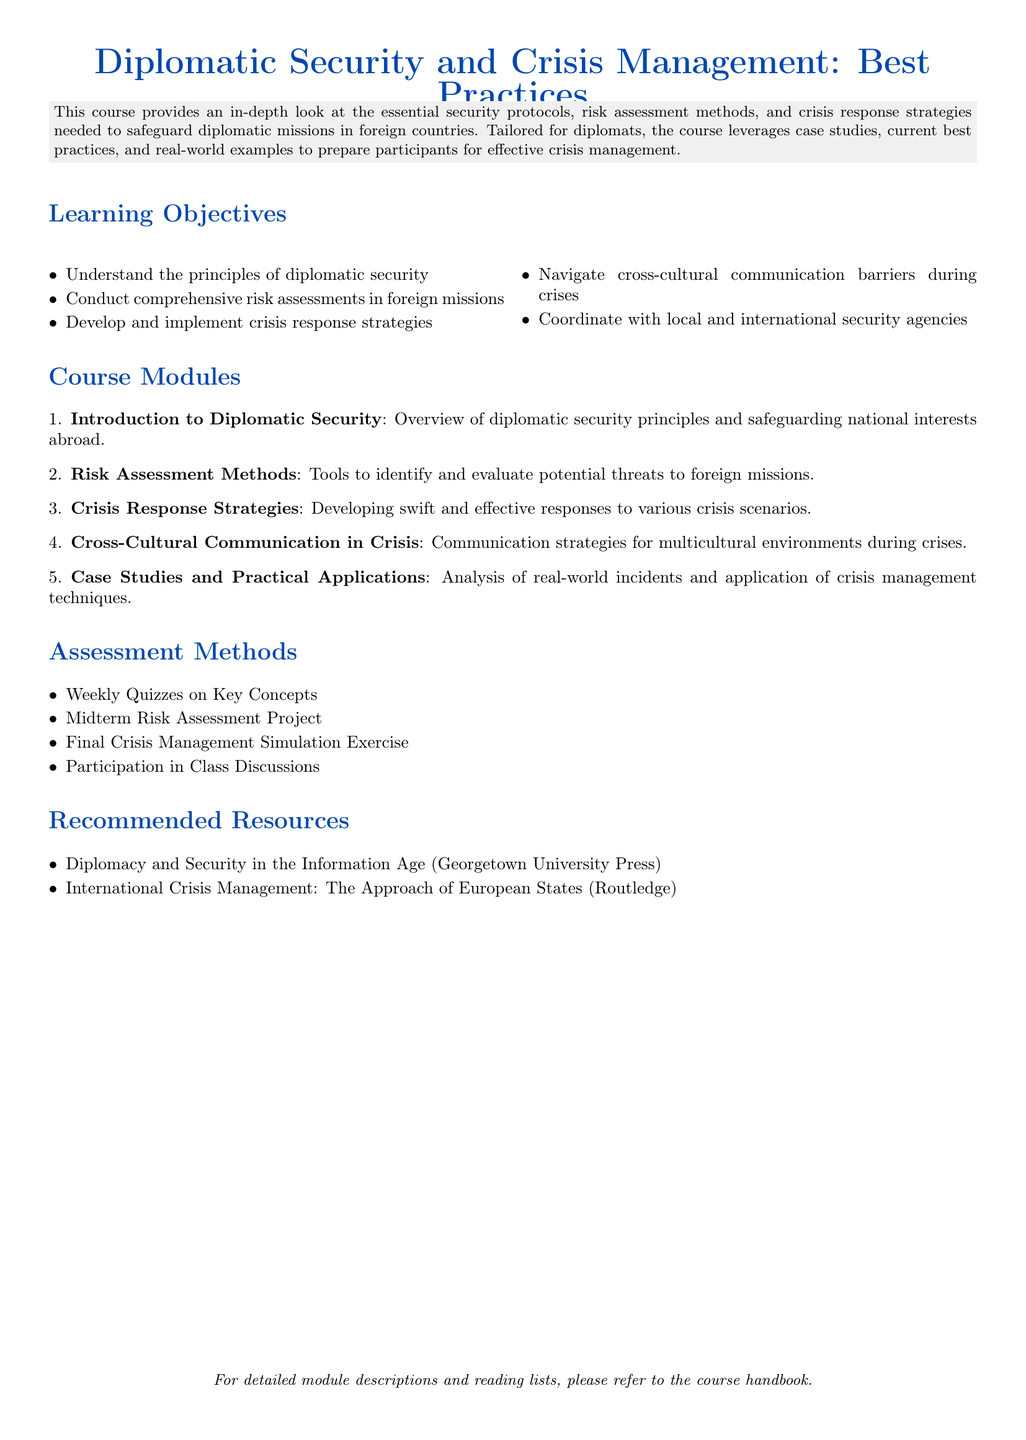What is the course title? The course title is stated at the beginning of the document.
Answer: Diplomatic Security and Crisis Management: Best Practices How many modules are listed in the syllabus? The number of modules can be counted from the enumerated list in the course modules section.
Answer: Five What is one recommended resource for the course? The document lists recommended resources in a specific section.
Answer: Diplomacy and Security in the Information Age What is the first learning objective? The learning objectives are listed in a specific order.
Answer: Understand the principles of diplomatic security What type of exercise is included in the assessment methods? The assessment methods list different types of evaluations for the course.
Answer: Final Crisis Management Simulation Exercise What is the focus of the second module? The modules provide specific focuses as outlined in the syllabus.
Answer: Risk Assessment Methods What is the purpose of "Case Studies and Practical Applications" module? The title suggests a focus on real-world incidents and practical techniques.
Answer: Analysis of real-world incidents What communication aspect is covered in the course? The learning objectives mention specific areas of focus including communications during crises.
Answer: Cross-cultural communication barriers during crises Which agency type is emphasized for coordination? The document explicitly states the type of agencies to coordinate with during crises.
Answer: Local and international security agencies 